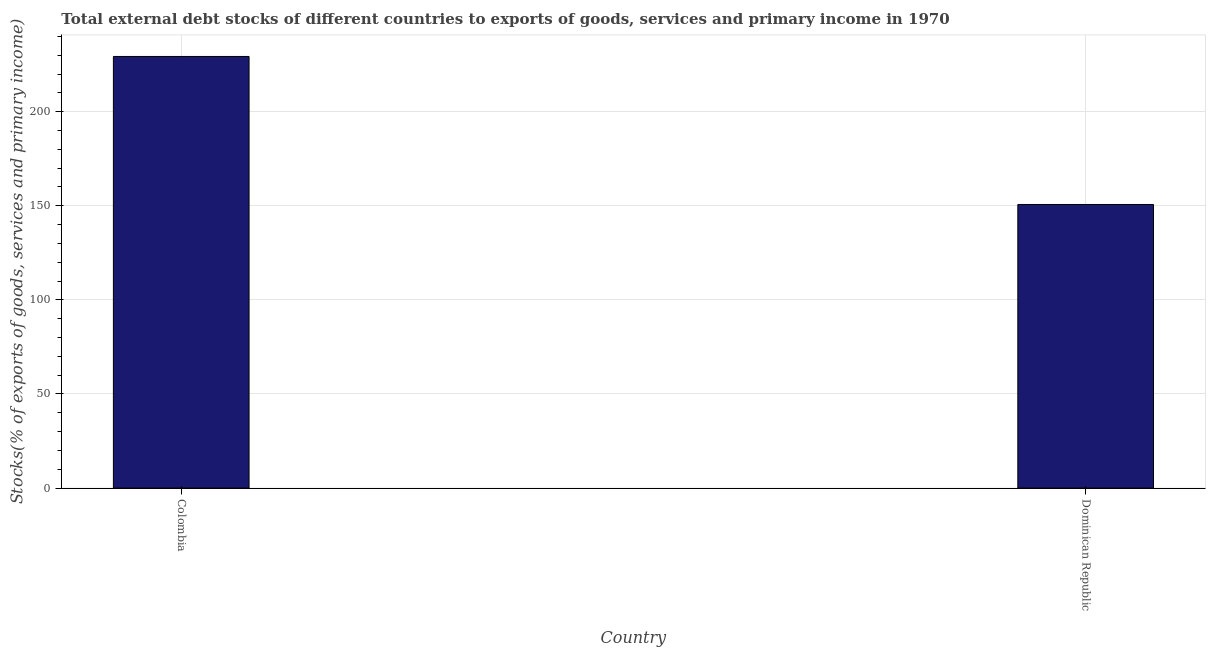Does the graph contain any zero values?
Keep it short and to the point. No. What is the title of the graph?
Your answer should be compact. Total external debt stocks of different countries to exports of goods, services and primary income in 1970. What is the label or title of the Y-axis?
Ensure brevity in your answer.  Stocks(% of exports of goods, services and primary income). What is the external debt stocks in Colombia?
Provide a short and direct response. 229.35. Across all countries, what is the maximum external debt stocks?
Offer a very short reply. 229.35. Across all countries, what is the minimum external debt stocks?
Provide a short and direct response. 150.7. In which country was the external debt stocks maximum?
Give a very brief answer. Colombia. In which country was the external debt stocks minimum?
Provide a succinct answer. Dominican Republic. What is the sum of the external debt stocks?
Provide a short and direct response. 380.05. What is the difference between the external debt stocks in Colombia and Dominican Republic?
Keep it short and to the point. 78.65. What is the average external debt stocks per country?
Offer a terse response. 190.02. What is the median external debt stocks?
Keep it short and to the point. 190.02. What is the ratio of the external debt stocks in Colombia to that in Dominican Republic?
Provide a short and direct response. 1.52. Is the external debt stocks in Colombia less than that in Dominican Republic?
Offer a terse response. No. In how many countries, is the external debt stocks greater than the average external debt stocks taken over all countries?
Keep it short and to the point. 1. How many bars are there?
Give a very brief answer. 2. Are all the bars in the graph horizontal?
Offer a very short reply. No. What is the difference between two consecutive major ticks on the Y-axis?
Ensure brevity in your answer.  50. Are the values on the major ticks of Y-axis written in scientific E-notation?
Provide a short and direct response. No. What is the Stocks(% of exports of goods, services and primary income) in Colombia?
Ensure brevity in your answer.  229.35. What is the Stocks(% of exports of goods, services and primary income) in Dominican Republic?
Your response must be concise. 150.7. What is the difference between the Stocks(% of exports of goods, services and primary income) in Colombia and Dominican Republic?
Ensure brevity in your answer.  78.65. What is the ratio of the Stocks(% of exports of goods, services and primary income) in Colombia to that in Dominican Republic?
Keep it short and to the point. 1.52. 